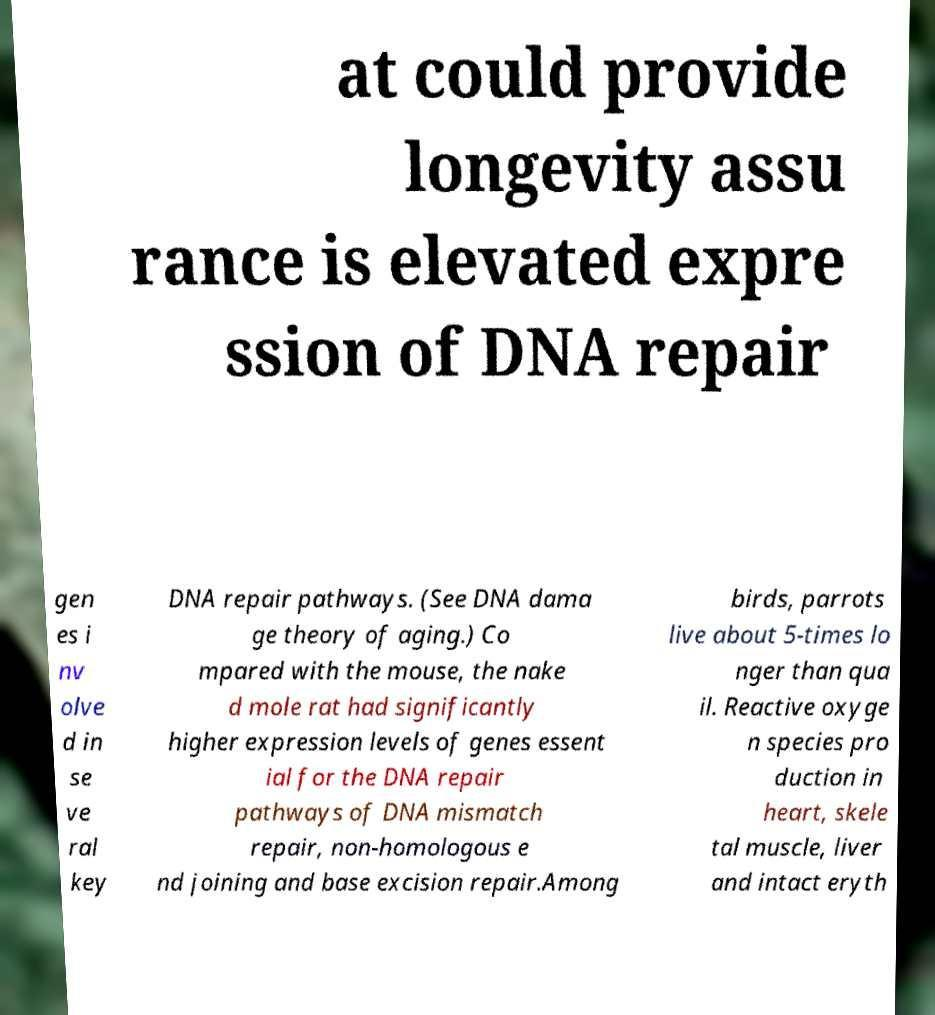Can you accurately transcribe the text from the provided image for me? at could provide longevity assu rance is elevated expre ssion of DNA repair gen es i nv olve d in se ve ral key DNA repair pathways. (See DNA dama ge theory of aging.) Co mpared with the mouse, the nake d mole rat had significantly higher expression levels of genes essent ial for the DNA repair pathways of DNA mismatch repair, non-homologous e nd joining and base excision repair.Among birds, parrots live about 5-times lo nger than qua il. Reactive oxyge n species pro duction in heart, skele tal muscle, liver and intact eryth 